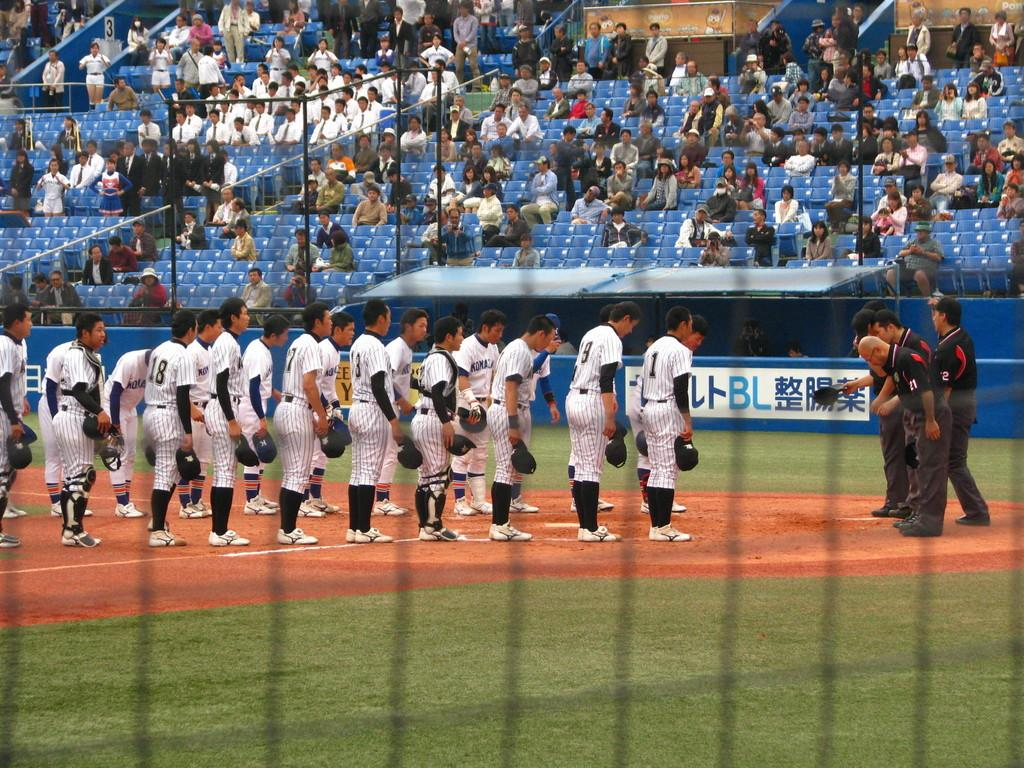<image>
Share a concise interpretation of the image provided. Players and umpires bow to one another, including the player wearing number 1. 